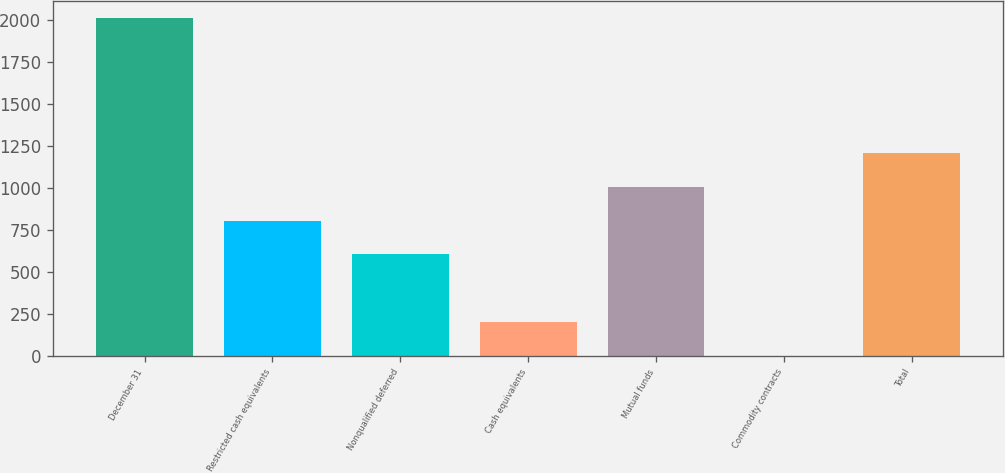Convert chart to OTSL. <chart><loc_0><loc_0><loc_500><loc_500><bar_chart><fcel>December 31<fcel>Restricted cash equivalents<fcel>Nonqualified deferred<fcel>Cash equivalents<fcel>Mutual funds<fcel>Commodity contracts<fcel>Total<nl><fcel>2015<fcel>806.6<fcel>605.2<fcel>202.4<fcel>1008<fcel>1<fcel>1209.4<nl></chart> 